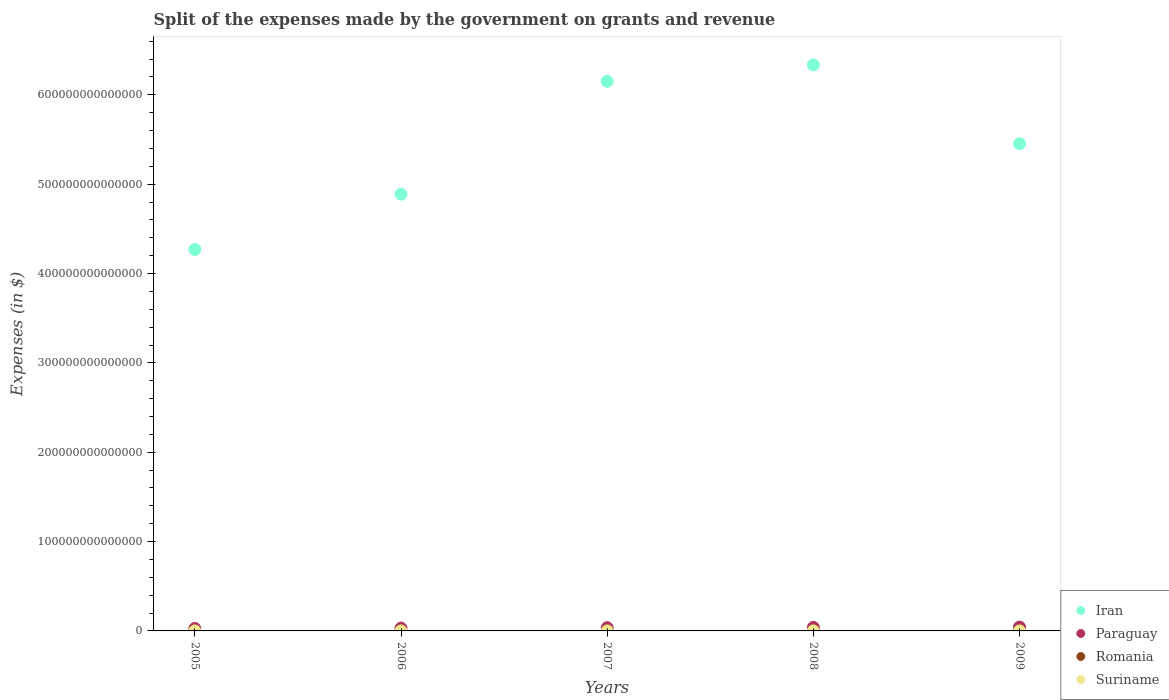Is the number of dotlines equal to the number of legend labels?
Your answer should be very brief. Yes. What is the expenses made by the government on grants and revenue in Iran in 2007?
Your answer should be very brief. 6.15e+14. Across all years, what is the maximum expenses made by the government on grants and revenue in Paraguay?
Provide a short and direct response. 4.32e+12. Across all years, what is the minimum expenses made by the government on grants and revenue in Iran?
Your answer should be very brief. 4.27e+14. What is the total expenses made by the government on grants and revenue in Paraguay in the graph?
Ensure brevity in your answer.  1.77e+13. What is the difference between the expenses made by the government on grants and revenue in Iran in 2005 and that in 2007?
Your response must be concise. -1.88e+14. What is the difference between the expenses made by the government on grants and revenue in Suriname in 2007 and the expenses made by the government on grants and revenue in Iran in 2008?
Your answer should be compact. -6.34e+14. What is the average expenses made by the government on grants and revenue in Romania per year?
Your answer should be very brief. 1.44e+1. In the year 2008, what is the difference between the expenses made by the government on grants and revenue in Paraguay and expenses made by the government on grants and revenue in Iran?
Offer a terse response. -6.30e+14. In how many years, is the expenses made by the government on grants and revenue in Paraguay greater than 300000000000000 $?
Your response must be concise. 0. What is the ratio of the expenses made by the government on grants and revenue in Paraguay in 2005 to that in 2006?
Ensure brevity in your answer.  0.86. Is the expenses made by the government on grants and revenue in Iran in 2005 less than that in 2007?
Offer a terse response. Yes. Is the difference between the expenses made by the government on grants and revenue in Paraguay in 2006 and 2009 greater than the difference between the expenses made by the government on grants and revenue in Iran in 2006 and 2009?
Your response must be concise. Yes. What is the difference between the highest and the second highest expenses made by the government on grants and revenue in Romania?
Offer a very short reply. 4.70e+09. What is the difference between the highest and the lowest expenses made by the government on grants and revenue in Suriname?
Make the answer very short. 7.19e+08. In how many years, is the expenses made by the government on grants and revenue in Paraguay greater than the average expenses made by the government on grants and revenue in Paraguay taken over all years?
Offer a terse response. 3. Is the sum of the expenses made by the government on grants and revenue in Romania in 2006 and 2007 greater than the maximum expenses made by the government on grants and revenue in Suriname across all years?
Offer a terse response. Yes. Is it the case that in every year, the sum of the expenses made by the government on grants and revenue in Suriname and expenses made by the government on grants and revenue in Romania  is greater than the sum of expenses made by the government on grants and revenue in Paraguay and expenses made by the government on grants and revenue in Iran?
Make the answer very short. No. Is it the case that in every year, the sum of the expenses made by the government on grants and revenue in Romania and expenses made by the government on grants and revenue in Suriname  is greater than the expenses made by the government on grants and revenue in Paraguay?
Keep it short and to the point. No. Is the expenses made by the government on grants and revenue in Iran strictly greater than the expenses made by the government on grants and revenue in Paraguay over the years?
Give a very brief answer. Yes. What is the difference between two consecutive major ticks on the Y-axis?
Provide a short and direct response. 1.00e+14. Are the values on the major ticks of Y-axis written in scientific E-notation?
Ensure brevity in your answer.  No. Does the graph contain any zero values?
Offer a very short reply. No. Where does the legend appear in the graph?
Offer a very short reply. Bottom right. What is the title of the graph?
Provide a short and direct response. Split of the expenses made by the government on grants and revenue. What is the label or title of the Y-axis?
Make the answer very short. Expenses (in $). What is the Expenses (in $) in Iran in 2005?
Keep it short and to the point. 4.27e+14. What is the Expenses (in $) in Paraguay in 2005?
Offer a terse response. 2.72e+12. What is the Expenses (in $) of Romania in 2005?
Offer a very short reply. 9.15e+09. What is the Expenses (in $) in Suriname in 2005?
Make the answer very short. 3.94e+08. What is the Expenses (in $) of Iran in 2006?
Give a very brief answer. 4.89e+14. What is the Expenses (in $) in Paraguay in 2006?
Provide a short and direct response. 3.17e+12. What is the Expenses (in $) of Romania in 2006?
Ensure brevity in your answer.  1.15e+1. What is the Expenses (in $) in Suriname in 2006?
Provide a short and direct response. 5.33e+08. What is the Expenses (in $) of Iran in 2007?
Your response must be concise. 6.15e+14. What is the Expenses (in $) in Paraguay in 2007?
Provide a succinct answer. 3.61e+12. What is the Expenses (in $) in Romania in 2007?
Offer a terse response. 1.50e+1. What is the Expenses (in $) in Suriname in 2007?
Your answer should be very brief. 8.47e+08. What is the Expenses (in $) of Iran in 2008?
Ensure brevity in your answer.  6.34e+14. What is the Expenses (in $) in Paraguay in 2008?
Your answer should be very brief. 3.91e+12. What is the Expenses (in $) of Romania in 2008?
Your response must be concise. 1.59e+1. What is the Expenses (in $) in Suriname in 2008?
Your answer should be very brief. 6.72e+08. What is the Expenses (in $) in Iran in 2009?
Offer a very short reply. 5.45e+14. What is the Expenses (in $) of Paraguay in 2009?
Provide a short and direct response. 4.32e+12. What is the Expenses (in $) in Romania in 2009?
Your response must be concise. 2.06e+1. What is the Expenses (in $) in Suriname in 2009?
Offer a terse response. 1.11e+09. Across all years, what is the maximum Expenses (in $) of Iran?
Make the answer very short. 6.34e+14. Across all years, what is the maximum Expenses (in $) of Paraguay?
Offer a very short reply. 4.32e+12. Across all years, what is the maximum Expenses (in $) in Romania?
Your response must be concise. 2.06e+1. Across all years, what is the maximum Expenses (in $) of Suriname?
Offer a very short reply. 1.11e+09. Across all years, what is the minimum Expenses (in $) in Iran?
Provide a succinct answer. 4.27e+14. Across all years, what is the minimum Expenses (in $) in Paraguay?
Offer a very short reply. 2.72e+12. Across all years, what is the minimum Expenses (in $) in Romania?
Give a very brief answer. 9.15e+09. Across all years, what is the minimum Expenses (in $) in Suriname?
Provide a succinct answer. 3.94e+08. What is the total Expenses (in $) of Iran in the graph?
Offer a terse response. 2.71e+15. What is the total Expenses (in $) in Paraguay in the graph?
Offer a terse response. 1.77e+13. What is the total Expenses (in $) of Romania in the graph?
Provide a short and direct response. 7.21e+1. What is the total Expenses (in $) in Suriname in the graph?
Provide a succinct answer. 3.56e+09. What is the difference between the Expenses (in $) of Iran in 2005 and that in 2006?
Your answer should be compact. -6.19e+13. What is the difference between the Expenses (in $) of Paraguay in 2005 and that in 2006?
Your answer should be very brief. -4.46e+11. What is the difference between the Expenses (in $) of Romania in 2005 and that in 2006?
Your response must be concise. -2.31e+09. What is the difference between the Expenses (in $) of Suriname in 2005 and that in 2006?
Keep it short and to the point. -1.39e+08. What is the difference between the Expenses (in $) in Iran in 2005 and that in 2007?
Provide a short and direct response. -1.88e+14. What is the difference between the Expenses (in $) of Paraguay in 2005 and that in 2007?
Offer a very short reply. -8.87e+11. What is the difference between the Expenses (in $) of Romania in 2005 and that in 2007?
Give a very brief answer. -5.84e+09. What is the difference between the Expenses (in $) in Suriname in 2005 and that in 2007?
Give a very brief answer. -4.53e+08. What is the difference between the Expenses (in $) in Iran in 2005 and that in 2008?
Your answer should be very brief. -2.07e+14. What is the difference between the Expenses (in $) of Paraguay in 2005 and that in 2008?
Your answer should be very brief. -1.18e+12. What is the difference between the Expenses (in $) in Romania in 2005 and that in 2008?
Keep it short and to the point. -6.76e+09. What is the difference between the Expenses (in $) in Suriname in 2005 and that in 2008?
Keep it short and to the point. -2.78e+08. What is the difference between the Expenses (in $) of Iran in 2005 and that in 2009?
Ensure brevity in your answer.  -1.18e+14. What is the difference between the Expenses (in $) in Paraguay in 2005 and that in 2009?
Give a very brief answer. -1.60e+12. What is the difference between the Expenses (in $) of Romania in 2005 and that in 2009?
Provide a short and direct response. -1.15e+1. What is the difference between the Expenses (in $) of Suriname in 2005 and that in 2009?
Give a very brief answer. -7.19e+08. What is the difference between the Expenses (in $) in Iran in 2006 and that in 2007?
Offer a very short reply. -1.26e+14. What is the difference between the Expenses (in $) of Paraguay in 2006 and that in 2007?
Your response must be concise. -4.42e+11. What is the difference between the Expenses (in $) in Romania in 2006 and that in 2007?
Your response must be concise. -3.54e+09. What is the difference between the Expenses (in $) in Suriname in 2006 and that in 2007?
Keep it short and to the point. -3.14e+08. What is the difference between the Expenses (in $) of Iran in 2006 and that in 2008?
Your answer should be very brief. -1.45e+14. What is the difference between the Expenses (in $) in Paraguay in 2006 and that in 2008?
Provide a short and direct response. -7.36e+11. What is the difference between the Expenses (in $) of Romania in 2006 and that in 2008?
Offer a very short reply. -4.45e+09. What is the difference between the Expenses (in $) of Suriname in 2006 and that in 2008?
Keep it short and to the point. -1.39e+08. What is the difference between the Expenses (in $) in Iran in 2006 and that in 2009?
Give a very brief answer. -5.64e+13. What is the difference between the Expenses (in $) of Paraguay in 2006 and that in 2009?
Provide a short and direct response. -1.15e+12. What is the difference between the Expenses (in $) in Romania in 2006 and that in 2009?
Offer a very short reply. -9.15e+09. What is the difference between the Expenses (in $) of Suriname in 2006 and that in 2009?
Provide a short and direct response. -5.80e+08. What is the difference between the Expenses (in $) in Iran in 2007 and that in 2008?
Provide a short and direct response. -1.84e+13. What is the difference between the Expenses (in $) of Paraguay in 2007 and that in 2008?
Offer a terse response. -2.95e+11. What is the difference between the Expenses (in $) in Romania in 2007 and that in 2008?
Make the answer very short. -9.14e+08. What is the difference between the Expenses (in $) in Suriname in 2007 and that in 2008?
Ensure brevity in your answer.  1.75e+08. What is the difference between the Expenses (in $) in Iran in 2007 and that in 2009?
Ensure brevity in your answer.  6.99e+13. What is the difference between the Expenses (in $) in Paraguay in 2007 and that in 2009?
Make the answer very short. -7.09e+11. What is the difference between the Expenses (in $) in Romania in 2007 and that in 2009?
Ensure brevity in your answer.  -5.61e+09. What is the difference between the Expenses (in $) in Suriname in 2007 and that in 2009?
Provide a short and direct response. -2.66e+08. What is the difference between the Expenses (in $) in Iran in 2008 and that in 2009?
Give a very brief answer. 8.83e+13. What is the difference between the Expenses (in $) of Paraguay in 2008 and that in 2009?
Provide a succinct answer. -4.14e+11. What is the difference between the Expenses (in $) of Romania in 2008 and that in 2009?
Offer a very short reply. -4.70e+09. What is the difference between the Expenses (in $) of Suriname in 2008 and that in 2009?
Ensure brevity in your answer.  -4.41e+08. What is the difference between the Expenses (in $) in Iran in 2005 and the Expenses (in $) in Paraguay in 2006?
Make the answer very short. 4.24e+14. What is the difference between the Expenses (in $) of Iran in 2005 and the Expenses (in $) of Romania in 2006?
Your answer should be very brief. 4.27e+14. What is the difference between the Expenses (in $) of Iran in 2005 and the Expenses (in $) of Suriname in 2006?
Offer a terse response. 4.27e+14. What is the difference between the Expenses (in $) of Paraguay in 2005 and the Expenses (in $) of Romania in 2006?
Your answer should be compact. 2.71e+12. What is the difference between the Expenses (in $) of Paraguay in 2005 and the Expenses (in $) of Suriname in 2006?
Ensure brevity in your answer.  2.72e+12. What is the difference between the Expenses (in $) of Romania in 2005 and the Expenses (in $) of Suriname in 2006?
Ensure brevity in your answer.  8.61e+09. What is the difference between the Expenses (in $) of Iran in 2005 and the Expenses (in $) of Paraguay in 2007?
Keep it short and to the point. 4.23e+14. What is the difference between the Expenses (in $) in Iran in 2005 and the Expenses (in $) in Romania in 2007?
Provide a succinct answer. 4.27e+14. What is the difference between the Expenses (in $) in Iran in 2005 and the Expenses (in $) in Suriname in 2007?
Ensure brevity in your answer.  4.27e+14. What is the difference between the Expenses (in $) in Paraguay in 2005 and the Expenses (in $) in Romania in 2007?
Offer a very short reply. 2.71e+12. What is the difference between the Expenses (in $) in Paraguay in 2005 and the Expenses (in $) in Suriname in 2007?
Ensure brevity in your answer.  2.72e+12. What is the difference between the Expenses (in $) of Romania in 2005 and the Expenses (in $) of Suriname in 2007?
Offer a very short reply. 8.30e+09. What is the difference between the Expenses (in $) in Iran in 2005 and the Expenses (in $) in Paraguay in 2008?
Provide a short and direct response. 4.23e+14. What is the difference between the Expenses (in $) of Iran in 2005 and the Expenses (in $) of Romania in 2008?
Keep it short and to the point. 4.27e+14. What is the difference between the Expenses (in $) in Iran in 2005 and the Expenses (in $) in Suriname in 2008?
Provide a short and direct response. 4.27e+14. What is the difference between the Expenses (in $) of Paraguay in 2005 and the Expenses (in $) of Romania in 2008?
Your response must be concise. 2.71e+12. What is the difference between the Expenses (in $) in Paraguay in 2005 and the Expenses (in $) in Suriname in 2008?
Give a very brief answer. 2.72e+12. What is the difference between the Expenses (in $) of Romania in 2005 and the Expenses (in $) of Suriname in 2008?
Provide a short and direct response. 8.48e+09. What is the difference between the Expenses (in $) of Iran in 2005 and the Expenses (in $) of Paraguay in 2009?
Ensure brevity in your answer.  4.23e+14. What is the difference between the Expenses (in $) in Iran in 2005 and the Expenses (in $) in Romania in 2009?
Your answer should be compact. 4.27e+14. What is the difference between the Expenses (in $) in Iran in 2005 and the Expenses (in $) in Suriname in 2009?
Offer a very short reply. 4.27e+14. What is the difference between the Expenses (in $) in Paraguay in 2005 and the Expenses (in $) in Romania in 2009?
Make the answer very short. 2.70e+12. What is the difference between the Expenses (in $) of Paraguay in 2005 and the Expenses (in $) of Suriname in 2009?
Offer a terse response. 2.72e+12. What is the difference between the Expenses (in $) in Romania in 2005 and the Expenses (in $) in Suriname in 2009?
Ensure brevity in your answer.  8.03e+09. What is the difference between the Expenses (in $) of Iran in 2006 and the Expenses (in $) of Paraguay in 2007?
Give a very brief answer. 4.85e+14. What is the difference between the Expenses (in $) in Iran in 2006 and the Expenses (in $) in Romania in 2007?
Provide a succinct answer. 4.89e+14. What is the difference between the Expenses (in $) in Iran in 2006 and the Expenses (in $) in Suriname in 2007?
Provide a succinct answer. 4.89e+14. What is the difference between the Expenses (in $) of Paraguay in 2006 and the Expenses (in $) of Romania in 2007?
Ensure brevity in your answer.  3.15e+12. What is the difference between the Expenses (in $) of Paraguay in 2006 and the Expenses (in $) of Suriname in 2007?
Provide a succinct answer. 3.17e+12. What is the difference between the Expenses (in $) in Romania in 2006 and the Expenses (in $) in Suriname in 2007?
Ensure brevity in your answer.  1.06e+1. What is the difference between the Expenses (in $) of Iran in 2006 and the Expenses (in $) of Paraguay in 2008?
Keep it short and to the point. 4.85e+14. What is the difference between the Expenses (in $) of Iran in 2006 and the Expenses (in $) of Romania in 2008?
Make the answer very short. 4.89e+14. What is the difference between the Expenses (in $) of Iran in 2006 and the Expenses (in $) of Suriname in 2008?
Your answer should be very brief. 4.89e+14. What is the difference between the Expenses (in $) in Paraguay in 2006 and the Expenses (in $) in Romania in 2008?
Keep it short and to the point. 3.15e+12. What is the difference between the Expenses (in $) of Paraguay in 2006 and the Expenses (in $) of Suriname in 2008?
Offer a terse response. 3.17e+12. What is the difference between the Expenses (in $) in Romania in 2006 and the Expenses (in $) in Suriname in 2008?
Provide a short and direct response. 1.08e+1. What is the difference between the Expenses (in $) of Iran in 2006 and the Expenses (in $) of Paraguay in 2009?
Give a very brief answer. 4.85e+14. What is the difference between the Expenses (in $) in Iran in 2006 and the Expenses (in $) in Romania in 2009?
Offer a terse response. 4.89e+14. What is the difference between the Expenses (in $) of Iran in 2006 and the Expenses (in $) of Suriname in 2009?
Keep it short and to the point. 4.89e+14. What is the difference between the Expenses (in $) of Paraguay in 2006 and the Expenses (in $) of Romania in 2009?
Offer a terse response. 3.15e+12. What is the difference between the Expenses (in $) of Paraguay in 2006 and the Expenses (in $) of Suriname in 2009?
Keep it short and to the point. 3.17e+12. What is the difference between the Expenses (in $) of Romania in 2006 and the Expenses (in $) of Suriname in 2009?
Give a very brief answer. 1.03e+1. What is the difference between the Expenses (in $) in Iran in 2007 and the Expenses (in $) in Paraguay in 2008?
Make the answer very short. 6.11e+14. What is the difference between the Expenses (in $) in Iran in 2007 and the Expenses (in $) in Romania in 2008?
Ensure brevity in your answer.  6.15e+14. What is the difference between the Expenses (in $) in Iran in 2007 and the Expenses (in $) in Suriname in 2008?
Ensure brevity in your answer.  6.15e+14. What is the difference between the Expenses (in $) of Paraguay in 2007 and the Expenses (in $) of Romania in 2008?
Offer a very short reply. 3.59e+12. What is the difference between the Expenses (in $) of Paraguay in 2007 and the Expenses (in $) of Suriname in 2008?
Your response must be concise. 3.61e+12. What is the difference between the Expenses (in $) in Romania in 2007 and the Expenses (in $) in Suriname in 2008?
Your answer should be very brief. 1.43e+1. What is the difference between the Expenses (in $) in Iran in 2007 and the Expenses (in $) in Paraguay in 2009?
Provide a short and direct response. 6.11e+14. What is the difference between the Expenses (in $) in Iran in 2007 and the Expenses (in $) in Romania in 2009?
Your answer should be compact. 6.15e+14. What is the difference between the Expenses (in $) in Iran in 2007 and the Expenses (in $) in Suriname in 2009?
Provide a succinct answer. 6.15e+14. What is the difference between the Expenses (in $) in Paraguay in 2007 and the Expenses (in $) in Romania in 2009?
Provide a succinct answer. 3.59e+12. What is the difference between the Expenses (in $) in Paraguay in 2007 and the Expenses (in $) in Suriname in 2009?
Provide a succinct answer. 3.61e+12. What is the difference between the Expenses (in $) of Romania in 2007 and the Expenses (in $) of Suriname in 2009?
Offer a very short reply. 1.39e+1. What is the difference between the Expenses (in $) of Iran in 2008 and the Expenses (in $) of Paraguay in 2009?
Make the answer very short. 6.29e+14. What is the difference between the Expenses (in $) of Iran in 2008 and the Expenses (in $) of Romania in 2009?
Offer a very short reply. 6.34e+14. What is the difference between the Expenses (in $) in Iran in 2008 and the Expenses (in $) in Suriname in 2009?
Ensure brevity in your answer.  6.34e+14. What is the difference between the Expenses (in $) in Paraguay in 2008 and the Expenses (in $) in Romania in 2009?
Keep it short and to the point. 3.88e+12. What is the difference between the Expenses (in $) of Paraguay in 2008 and the Expenses (in $) of Suriname in 2009?
Make the answer very short. 3.90e+12. What is the difference between the Expenses (in $) of Romania in 2008 and the Expenses (in $) of Suriname in 2009?
Give a very brief answer. 1.48e+1. What is the average Expenses (in $) of Iran per year?
Your response must be concise. 5.42e+14. What is the average Expenses (in $) of Paraguay per year?
Your answer should be compact. 3.55e+12. What is the average Expenses (in $) of Romania per year?
Offer a very short reply. 1.44e+1. What is the average Expenses (in $) of Suriname per year?
Make the answer very short. 7.12e+08. In the year 2005, what is the difference between the Expenses (in $) of Iran and Expenses (in $) of Paraguay?
Offer a very short reply. 4.24e+14. In the year 2005, what is the difference between the Expenses (in $) of Iran and Expenses (in $) of Romania?
Your response must be concise. 4.27e+14. In the year 2005, what is the difference between the Expenses (in $) in Iran and Expenses (in $) in Suriname?
Your response must be concise. 4.27e+14. In the year 2005, what is the difference between the Expenses (in $) of Paraguay and Expenses (in $) of Romania?
Give a very brief answer. 2.71e+12. In the year 2005, what is the difference between the Expenses (in $) of Paraguay and Expenses (in $) of Suriname?
Your answer should be very brief. 2.72e+12. In the year 2005, what is the difference between the Expenses (in $) of Romania and Expenses (in $) of Suriname?
Make the answer very short. 8.75e+09. In the year 2006, what is the difference between the Expenses (in $) in Iran and Expenses (in $) in Paraguay?
Provide a succinct answer. 4.86e+14. In the year 2006, what is the difference between the Expenses (in $) of Iran and Expenses (in $) of Romania?
Your response must be concise. 4.89e+14. In the year 2006, what is the difference between the Expenses (in $) of Iran and Expenses (in $) of Suriname?
Your answer should be compact. 4.89e+14. In the year 2006, what is the difference between the Expenses (in $) of Paraguay and Expenses (in $) of Romania?
Keep it short and to the point. 3.16e+12. In the year 2006, what is the difference between the Expenses (in $) in Paraguay and Expenses (in $) in Suriname?
Give a very brief answer. 3.17e+12. In the year 2006, what is the difference between the Expenses (in $) in Romania and Expenses (in $) in Suriname?
Make the answer very short. 1.09e+1. In the year 2007, what is the difference between the Expenses (in $) in Iran and Expenses (in $) in Paraguay?
Give a very brief answer. 6.12e+14. In the year 2007, what is the difference between the Expenses (in $) of Iran and Expenses (in $) of Romania?
Make the answer very short. 6.15e+14. In the year 2007, what is the difference between the Expenses (in $) of Iran and Expenses (in $) of Suriname?
Your answer should be compact. 6.15e+14. In the year 2007, what is the difference between the Expenses (in $) in Paraguay and Expenses (in $) in Romania?
Keep it short and to the point. 3.60e+12. In the year 2007, what is the difference between the Expenses (in $) of Paraguay and Expenses (in $) of Suriname?
Offer a terse response. 3.61e+12. In the year 2007, what is the difference between the Expenses (in $) in Romania and Expenses (in $) in Suriname?
Give a very brief answer. 1.41e+1. In the year 2008, what is the difference between the Expenses (in $) in Iran and Expenses (in $) in Paraguay?
Give a very brief answer. 6.30e+14. In the year 2008, what is the difference between the Expenses (in $) in Iran and Expenses (in $) in Romania?
Your answer should be very brief. 6.34e+14. In the year 2008, what is the difference between the Expenses (in $) in Iran and Expenses (in $) in Suriname?
Your answer should be very brief. 6.34e+14. In the year 2008, what is the difference between the Expenses (in $) in Paraguay and Expenses (in $) in Romania?
Ensure brevity in your answer.  3.89e+12. In the year 2008, what is the difference between the Expenses (in $) of Paraguay and Expenses (in $) of Suriname?
Give a very brief answer. 3.90e+12. In the year 2008, what is the difference between the Expenses (in $) in Romania and Expenses (in $) in Suriname?
Your answer should be very brief. 1.52e+1. In the year 2009, what is the difference between the Expenses (in $) of Iran and Expenses (in $) of Paraguay?
Offer a very short reply. 5.41e+14. In the year 2009, what is the difference between the Expenses (in $) in Iran and Expenses (in $) in Romania?
Provide a succinct answer. 5.45e+14. In the year 2009, what is the difference between the Expenses (in $) in Iran and Expenses (in $) in Suriname?
Your answer should be very brief. 5.45e+14. In the year 2009, what is the difference between the Expenses (in $) of Paraguay and Expenses (in $) of Romania?
Ensure brevity in your answer.  4.30e+12. In the year 2009, what is the difference between the Expenses (in $) of Paraguay and Expenses (in $) of Suriname?
Your answer should be compact. 4.32e+12. In the year 2009, what is the difference between the Expenses (in $) of Romania and Expenses (in $) of Suriname?
Your answer should be compact. 1.95e+1. What is the ratio of the Expenses (in $) of Iran in 2005 to that in 2006?
Your response must be concise. 0.87. What is the ratio of the Expenses (in $) in Paraguay in 2005 to that in 2006?
Give a very brief answer. 0.86. What is the ratio of the Expenses (in $) of Romania in 2005 to that in 2006?
Provide a short and direct response. 0.8. What is the ratio of the Expenses (in $) of Suriname in 2005 to that in 2006?
Give a very brief answer. 0.74. What is the ratio of the Expenses (in $) of Iran in 2005 to that in 2007?
Make the answer very short. 0.69. What is the ratio of the Expenses (in $) in Paraguay in 2005 to that in 2007?
Your answer should be very brief. 0.75. What is the ratio of the Expenses (in $) in Romania in 2005 to that in 2007?
Your response must be concise. 0.61. What is the ratio of the Expenses (in $) in Suriname in 2005 to that in 2007?
Ensure brevity in your answer.  0.47. What is the ratio of the Expenses (in $) of Iran in 2005 to that in 2008?
Offer a terse response. 0.67. What is the ratio of the Expenses (in $) in Paraguay in 2005 to that in 2008?
Offer a terse response. 0.7. What is the ratio of the Expenses (in $) in Romania in 2005 to that in 2008?
Provide a short and direct response. 0.58. What is the ratio of the Expenses (in $) of Suriname in 2005 to that in 2008?
Keep it short and to the point. 0.59. What is the ratio of the Expenses (in $) of Iran in 2005 to that in 2009?
Your response must be concise. 0.78. What is the ratio of the Expenses (in $) of Paraguay in 2005 to that in 2009?
Your answer should be compact. 0.63. What is the ratio of the Expenses (in $) in Romania in 2005 to that in 2009?
Your answer should be compact. 0.44. What is the ratio of the Expenses (in $) of Suriname in 2005 to that in 2009?
Your answer should be compact. 0.35. What is the ratio of the Expenses (in $) of Iran in 2006 to that in 2007?
Make the answer very short. 0.79. What is the ratio of the Expenses (in $) in Paraguay in 2006 to that in 2007?
Provide a succinct answer. 0.88. What is the ratio of the Expenses (in $) in Romania in 2006 to that in 2007?
Offer a very short reply. 0.76. What is the ratio of the Expenses (in $) of Suriname in 2006 to that in 2007?
Provide a short and direct response. 0.63. What is the ratio of the Expenses (in $) of Iran in 2006 to that in 2008?
Your answer should be compact. 0.77. What is the ratio of the Expenses (in $) of Paraguay in 2006 to that in 2008?
Make the answer very short. 0.81. What is the ratio of the Expenses (in $) of Romania in 2006 to that in 2008?
Offer a very short reply. 0.72. What is the ratio of the Expenses (in $) in Suriname in 2006 to that in 2008?
Offer a terse response. 0.79. What is the ratio of the Expenses (in $) of Iran in 2006 to that in 2009?
Make the answer very short. 0.9. What is the ratio of the Expenses (in $) in Paraguay in 2006 to that in 2009?
Offer a terse response. 0.73. What is the ratio of the Expenses (in $) of Romania in 2006 to that in 2009?
Provide a succinct answer. 0.56. What is the ratio of the Expenses (in $) in Suriname in 2006 to that in 2009?
Ensure brevity in your answer.  0.48. What is the ratio of the Expenses (in $) of Paraguay in 2007 to that in 2008?
Give a very brief answer. 0.92. What is the ratio of the Expenses (in $) of Romania in 2007 to that in 2008?
Offer a terse response. 0.94. What is the ratio of the Expenses (in $) of Suriname in 2007 to that in 2008?
Offer a very short reply. 1.26. What is the ratio of the Expenses (in $) of Iran in 2007 to that in 2009?
Keep it short and to the point. 1.13. What is the ratio of the Expenses (in $) in Paraguay in 2007 to that in 2009?
Your answer should be compact. 0.84. What is the ratio of the Expenses (in $) of Romania in 2007 to that in 2009?
Your response must be concise. 0.73. What is the ratio of the Expenses (in $) in Suriname in 2007 to that in 2009?
Your answer should be compact. 0.76. What is the ratio of the Expenses (in $) of Iran in 2008 to that in 2009?
Keep it short and to the point. 1.16. What is the ratio of the Expenses (in $) in Paraguay in 2008 to that in 2009?
Keep it short and to the point. 0.9. What is the ratio of the Expenses (in $) in Romania in 2008 to that in 2009?
Your response must be concise. 0.77. What is the ratio of the Expenses (in $) of Suriname in 2008 to that in 2009?
Keep it short and to the point. 0.6. What is the difference between the highest and the second highest Expenses (in $) in Iran?
Offer a terse response. 1.84e+13. What is the difference between the highest and the second highest Expenses (in $) of Paraguay?
Offer a terse response. 4.14e+11. What is the difference between the highest and the second highest Expenses (in $) in Romania?
Offer a very short reply. 4.70e+09. What is the difference between the highest and the second highest Expenses (in $) of Suriname?
Your answer should be very brief. 2.66e+08. What is the difference between the highest and the lowest Expenses (in $) in Iran?
Your answer should be very brief. 2.07e+14. What is the difference between the highest and the lowest Expenses (in $) of Paraguay?
Your answer should be very brief. 1.60e+12. What is the difference between the highest and the lowest Expenses (in $) in Romania?
Provide a succinct answer. 1.15e+1. What is the difference between the highest and the lowest Expenses (in $) in Suriname?
Keep it short and to the point. 7.19e+08. 